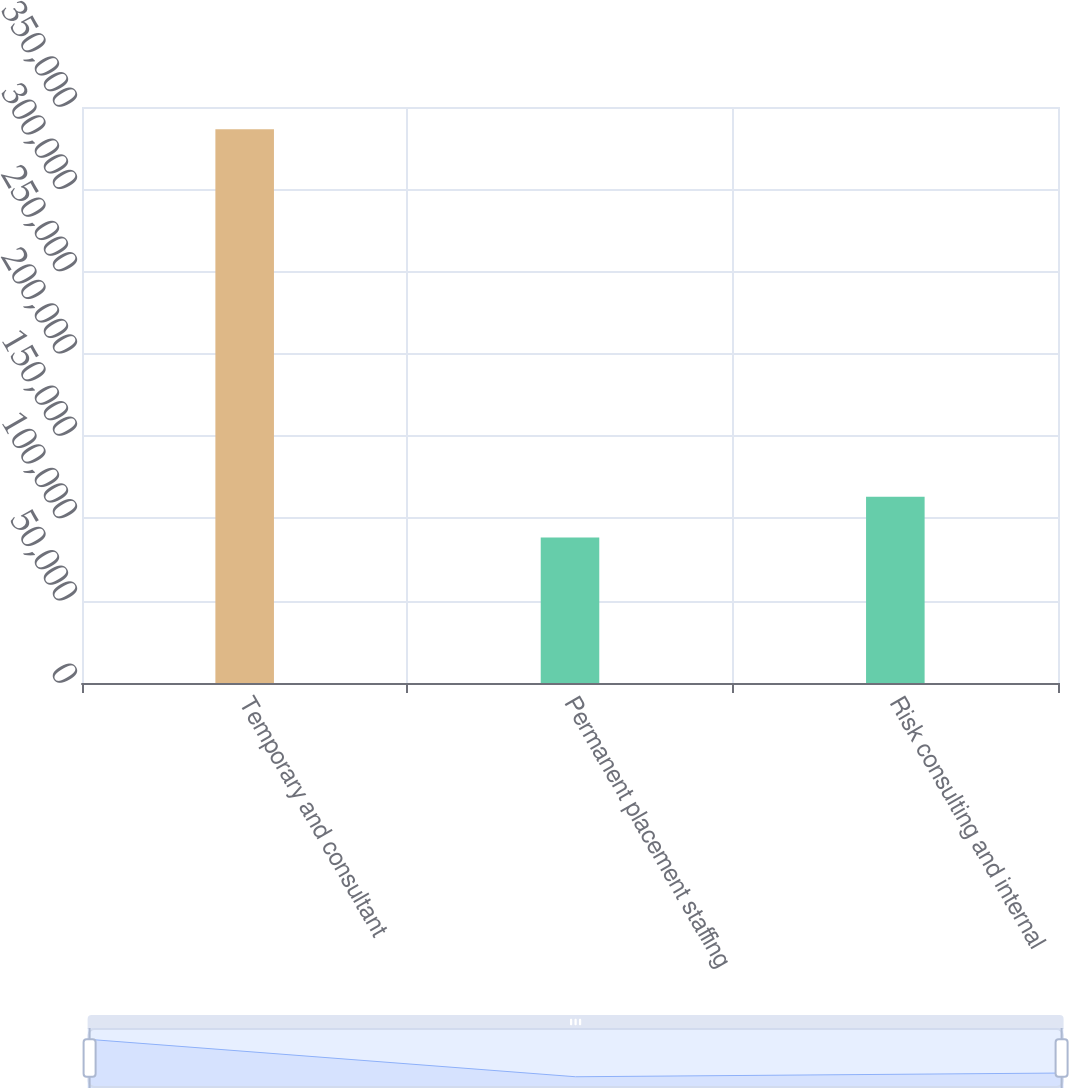Convert chart to OTSL. <chart><loc_0><loc_0><loc_500><loc_500><bar_chart><fcel>Temporary and consultant<fcel>Permanent placement staffing<fcel>Risk consulting and internal<nl><fcel>336468<fcel>88436<fcel>113239<nl></chart> 